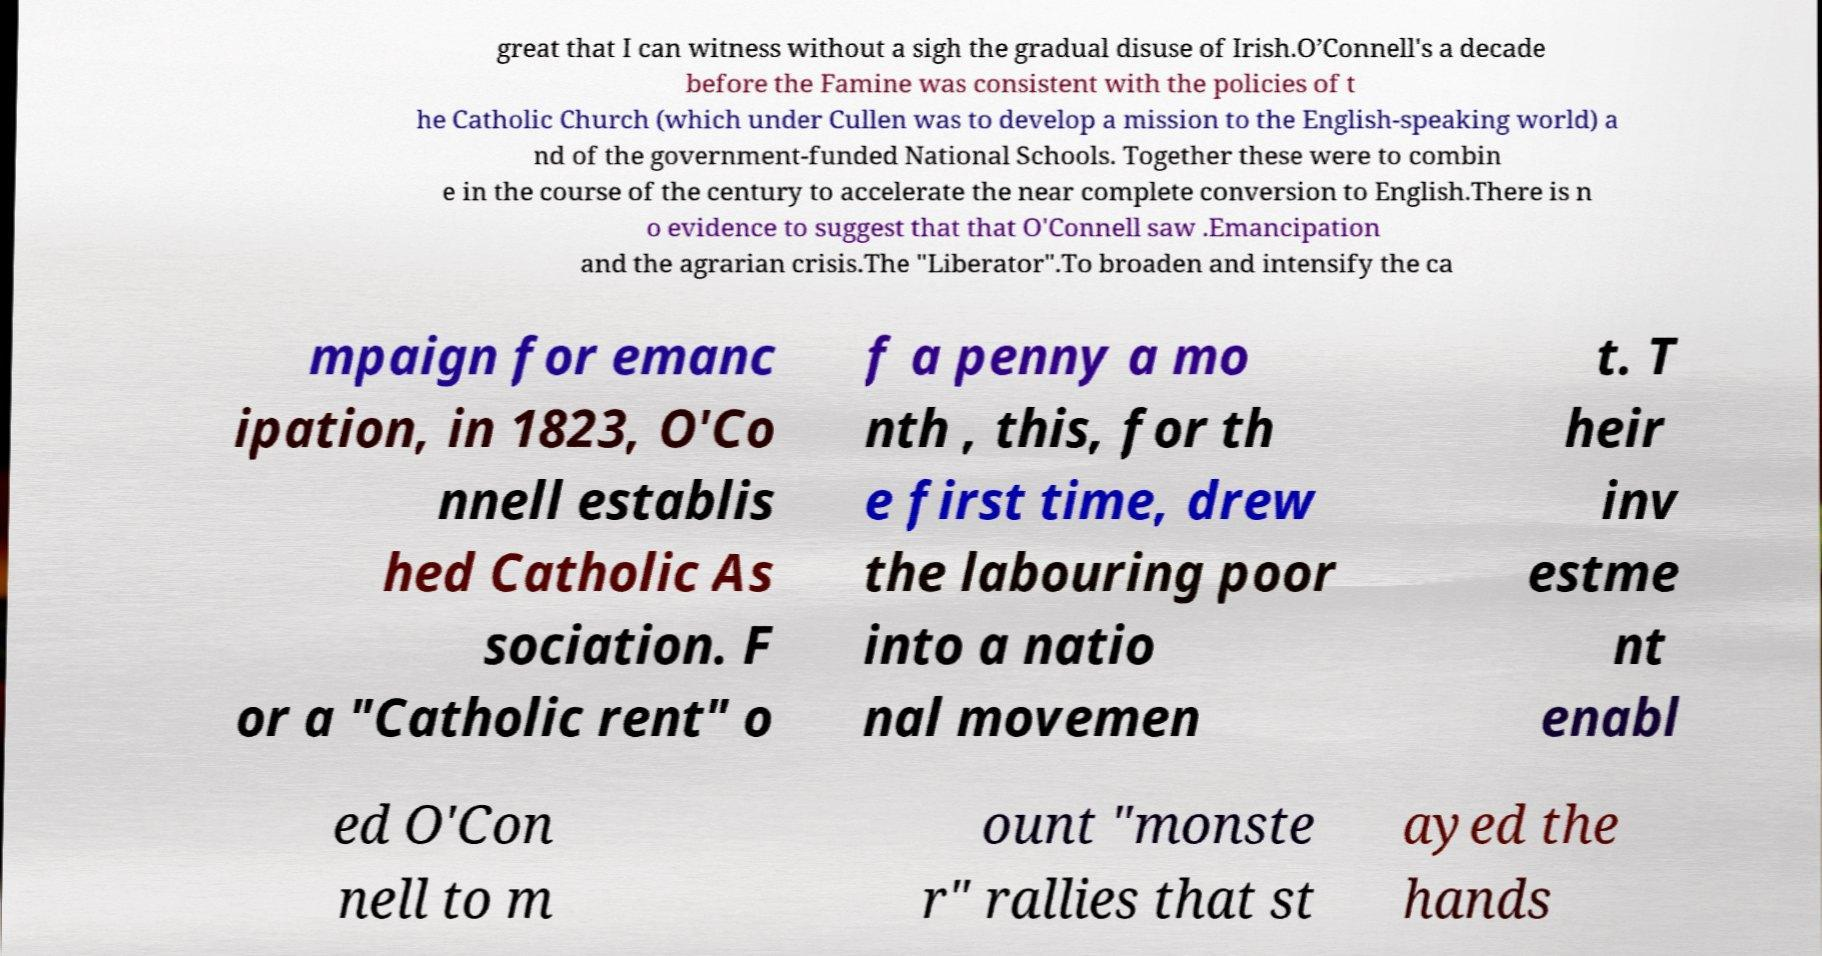I need the written content from this picture converted into text. Can you do that? great that I can witness without a sigh the gradual disuse of Irish.O’Connell's a decade before the Famine was consistent with the policies of t he Catholic Church (which under Cullen was to develop a mission to the English-speaking world) a nd of the government-funded National Schools. Together these were to combin e in the course of the century to accelerate the near complete conversion to English.There is n o evidence to suggest that that O'Connell saw .Emancipation and the agrarian crisis.The "Liberator".To broaden and intensify the ca mpaign for emanc ipation, in 1823, O'Co nnell establis hed Catholic As sociation. F or a "Catholic rent" o f a penny a mo nth , this, for th e first time, drew the labouring poor into a natio nal movemen t. T heir inv estme nt enabl ed O'Con nell to m ount "monste r" rallies that st ayed the hands 